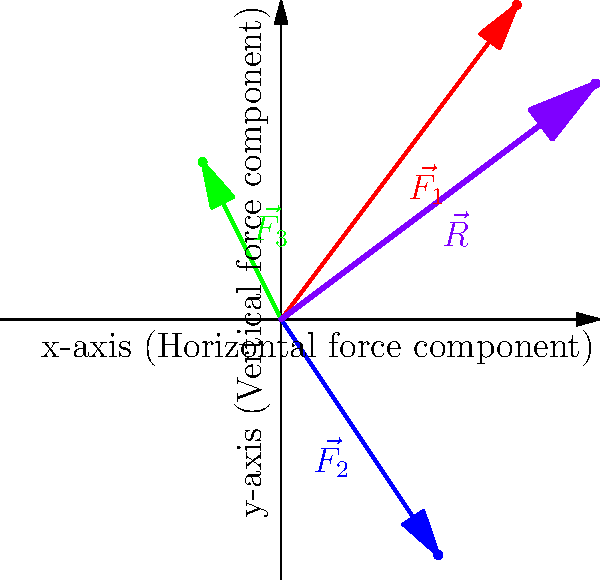In a compound exercise involving multiple muscle groups, three force vectors are acting on a joint: $\vec{F_1} = (3, 4)$, $\vec{F_2} = (2, -3)$, and $\vec{F_3} = (-1, 2)$. Calculate the magnitude of the resultant force vector $\vec{R}$ acting on the joint. To find the magnitude of the resultant force vector, we need to follow these steps:

1. Add the force vectors to find the resultant vector $\vec{R}$:
   $\vec{R} = \vec{F_1} + \vec{F_2} + \vec{F_3}$
   $\vec{R} = (3, 4) + (2, -3) + (-1, 2)$
   $\vec{R} = (3+2-1, 4-3+2)$
   $\vec{R} = (4, 3)$

2. Calculate the magnitude of $\vec{R}$ using the Pythagorean theorem:
   $|\vec{R}| = \sqrt{x^2 + y^2}$
   $|\vec{R}| = \sqrt{4^2 + 3^2}$
   $|\vec{R}| = \sqrt{16 + 9}$
   $|\vec{R}| = \sqrt{25}$
   $|\vec{R}| = 5$

Therefore, the magnitude of the resultant force vector $\vec{R}$ is 5 units.
Answer: 5 units 